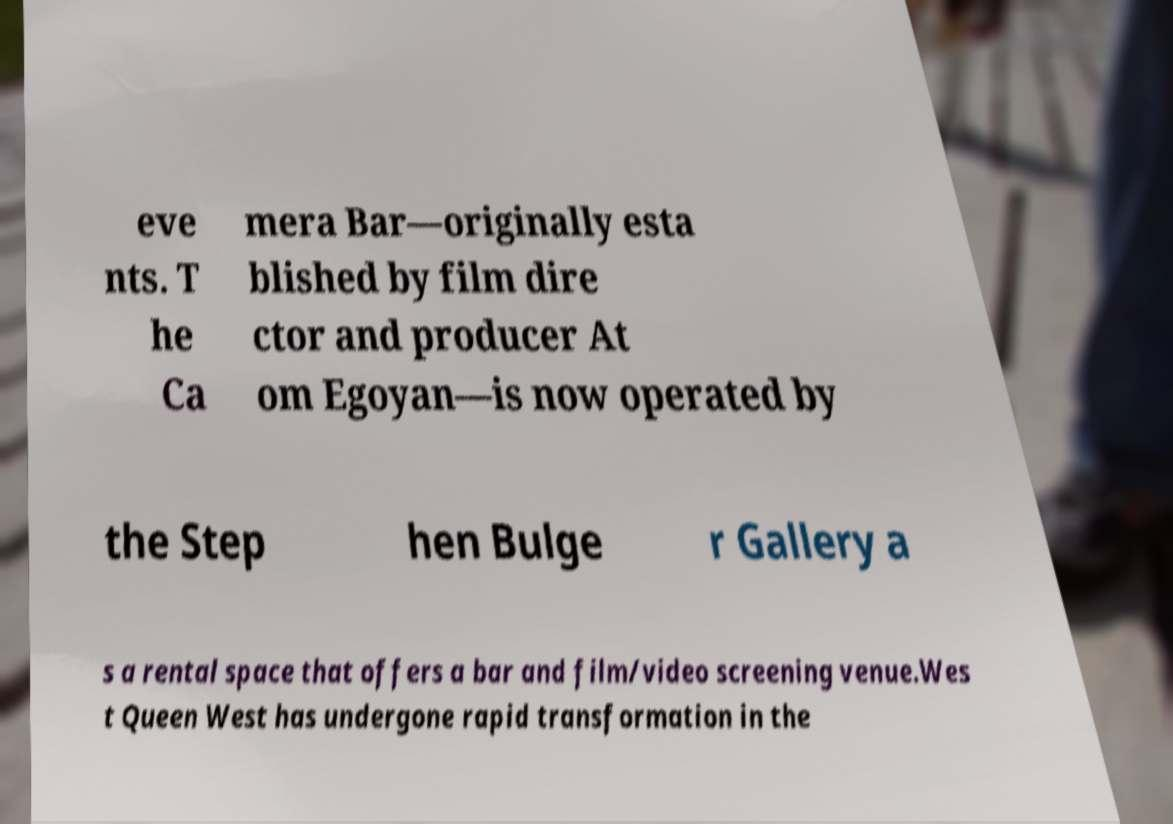What messages or text are displayed in this image? I need them in a readable, typed format. eve nts. T he Ca mera Bar—originally esta blished by film dire ctor and producer At om Egoyan—is now operated by the Step hen Bulge r Gallery a s a rental space that offers a bar and film/video screening venue.Wes t Queen West has undergone rapid transformation in the 